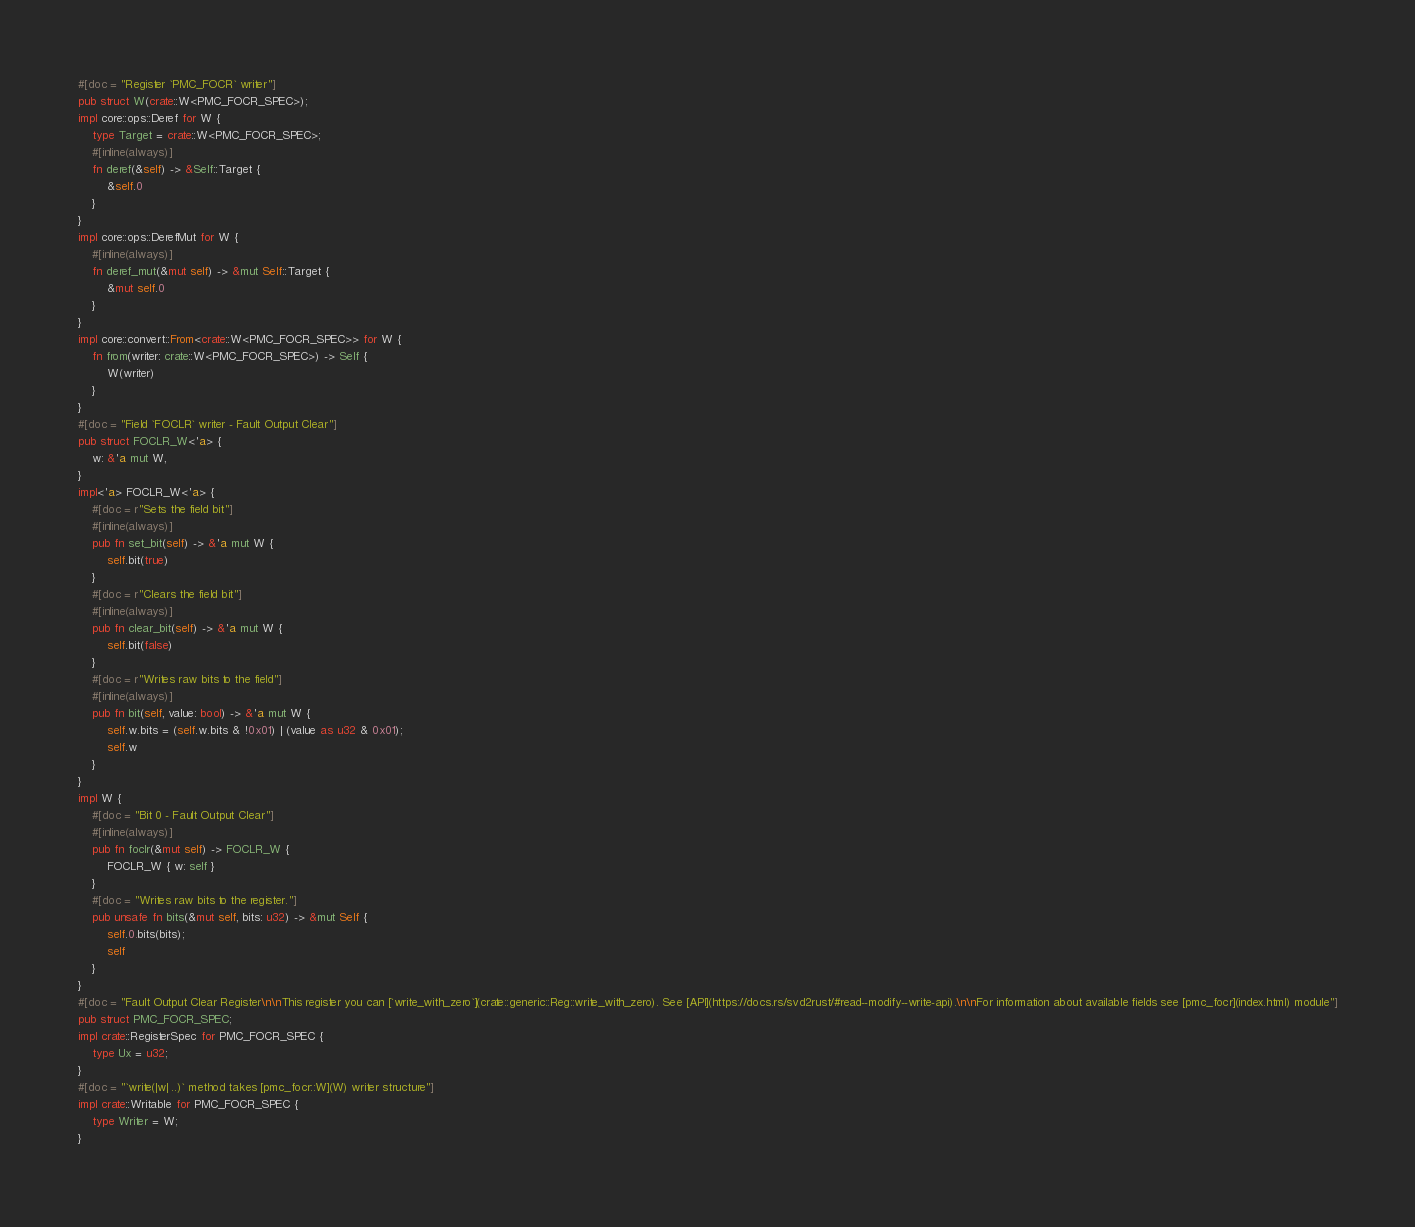Convert code to text. <code><loc_0><loc_0><loc_500><loc_500><_Rust_>#[doc = "Register `PMC_FOCR` writer"]
pub struct W(crate::W<PMC_FOCR_SPEC>);
impl core::ops::Deref for W {
    type Target = crate::W<PMC_FOCR_SPEC>;
    #[inline(always)]
    fn deref(&self) -> &Self::Target {
        &self.0
    }
}
impl core::ops::DerefMut for W {
    #[inline(always)]
    fn deref_mut(&mut self) -> &mut Self::Target {
        &mut self.0
    }
}
impl core::convert::From<crate::W<PMC_FOCR_SPEC>> for W {
    fn from(writer: crate::W<PMC_FOCR_SPEC>) -> Self {
        W(writer)
    }
}
#[doc = "Field `FOCLR` writer - Fault Output Clear"]
pub struct FOCLR_W<'a> {
    w: &'a mut W,
}
impl<'a> FOCLR_W<'a> {
    #[doc = r"Sets the field bit"]
    #[inline(always)]
    pub fn set_bit(self) -> &'a mut W {
        self.bit(true)
    }
    #[doc = r"Clears the field bit"]
    #[inline(always)]
    pub fn clear_bit(self) -> &'a mut W {
        self.bit(false)
    }
    #[doc = r"Writes raw bits to the field"]
    #[inline(always)]
    pub fn bit(self, value: bool) -> &'a mut W {
        self.w.bits = (self.w.bits & !0x01) | (value as u32 & 0x01);
        self.w
    }
}
impl W {
    #[doc = "Bit 0 - Fault Output Clear"]
    #[inline(always)]
    pub fn foclr(&mut self) -> FOCLR_W {
        FOCLR_W { w: self }
    }
    #[doc = "Writes raw bits to the register."]
    pub unsafe fn bits(&mut self, bits: u32) -> &mut Self {
        self.0.bits(bits);
        self
    }
}
#[doc = "Fault Output Clear Register\n\nThis register you can [`write_with_zero`](crate::generic::Reg::write_with_zero). See [API](https://docs.rs/svd2rust/#read--modify--write-api).\n\nFor information about available fields see [pmc_focr](index.html) module"]
pub struct PMC_FOCR_SPEC;
impl crate::RegisterSpec for PMC_FOCR_SPEC {
    type Ux = u32;
}
#[doc = "`write(|w| ..)` method takes [pmc_focr::W](W) writer structure"]
impl crate::Writable for PMC_FOCR_SPEC {
    type Writer = W;
}
</code> 